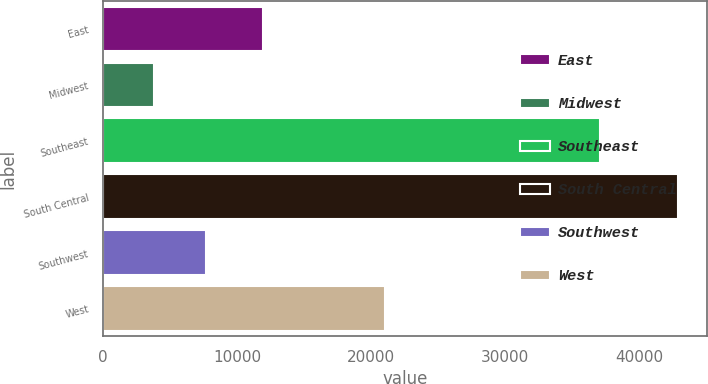Convert chart to OTSL. <chart><loc_0><loc_0><loc_500><loc_500><bar_chart><fcel>East<fcel>Midwest<fcel>Southeast<fcel>South Central<fcel>Southwest<fcel>West<nl><fcel>11900<fcel>3800<fcel>37100<fcel>42900<fcel>7710<fcel>21000<nl></chart> 